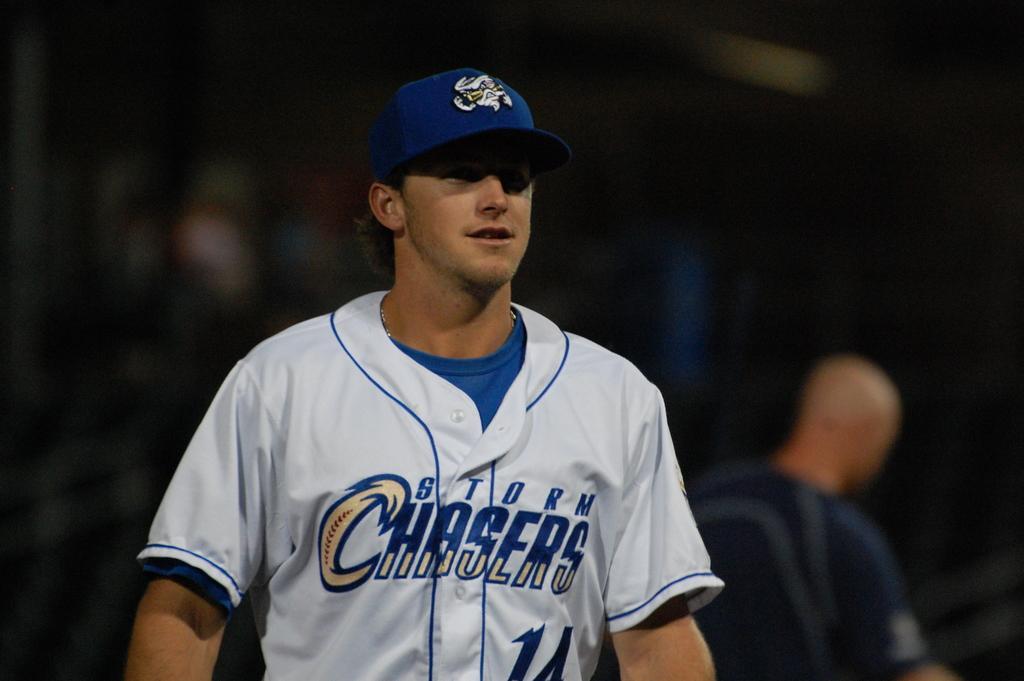Could you give a brief overview of what you see in this image? In the center of the image we can see a man standing. He is wearing a cap. In the background there is another man. 